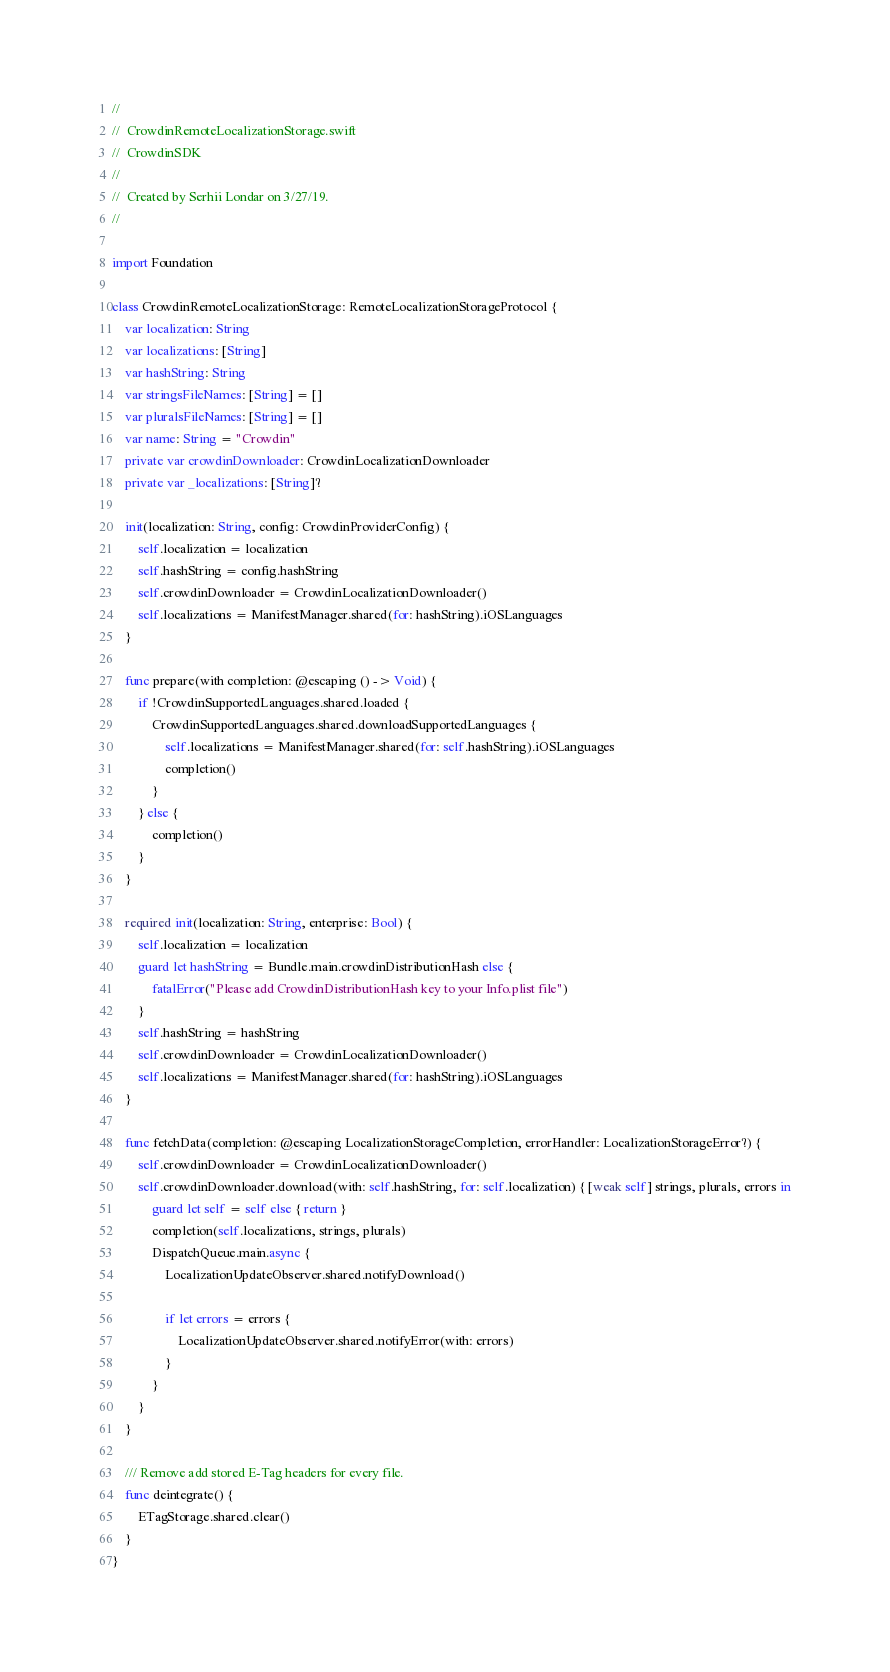Convert code to text. <code><loc_0><loc_0><loc_500><loc_500><_Swift_>//
//  CrowdinRemoteLocalizationStorage.swift
//  CrowdinSDK
//
//  Created by Serhii Londar on 3/27/19.
//

import Foundation

class CrowdinRemoteLocalizationStorage: RemoteLocalizationStorageProtocol {
    var localization: String
    var localizations: [String]
    var hashString: String
    var stringsFileNames: [String] = []
    var pluralsFileNames: [String] = []
    var name: String = "Crowdin"
    private var crowdinDownloader: CrowdinLocalizationDownloader
    private var _localizations: [String]?
    
    init(localization: String, config: CrowdinProviderConfig) {
        self.localization = localization
        self.hashString = config.hashString
        self.crowdinDownloader = CrowdinLocalizationDownloader()
        self.localizations = ManifestManager.shared(for: hashString).iOSLanguages
    }
    
    func prepare(with completion: @escaping () -> Void) {
        if !CrowdinSupportedLanguages.shared.loaded {
            CrowdinSupportedLanguages.shared.downloadSupportedLanguages {
                self.localizations = ManifestManager.shared(for: self.hashString).iOSLanguages
                completion()
            }
        } else {
            completion()
        }
    }
    
    required init(localization: String, enterprise: Bool) {
        self.localization = localization
        guard let hashString = Bundle.main.crowdinDistributionHash else {
            fatalError("Please add CrowdinDistributionHash key to your Info.plist file")
        }
        self.hashString = hashString
        self.crowdinDownloader = CrowdinLocalizationDownloader()
        self.localizations = ManifestManager.shared(for: hashString).iOSLanguages
    }
    
    func fetchData(completion: @escaping LocalizationStorageCompletion, errorHandler: LocalizationStorageError?) {
        self.crowdinDownloader = CrowdinLocalizationDownloader()
        self.crowdinDownloader.download(with: self.hashString, for: self.localization) { [weak self] strings, plurals, errors in
            guard let self = self else { return }
            completion(self.localizations, strings, plurals)
            DispatchQueue.main.async {
                LocalizationUpdateObserver.shared.notifyDownload()
                
                if let errors = errors {
                    LocalizationUpdateObserver.shared.notifyError(with: errors)
                }
            }
        }
    }
    
    /// Remove add stored E-Tag headers for every file.
    func deintegrate() {
        ETagStorage.shared.clear()
    }
}
</code> 